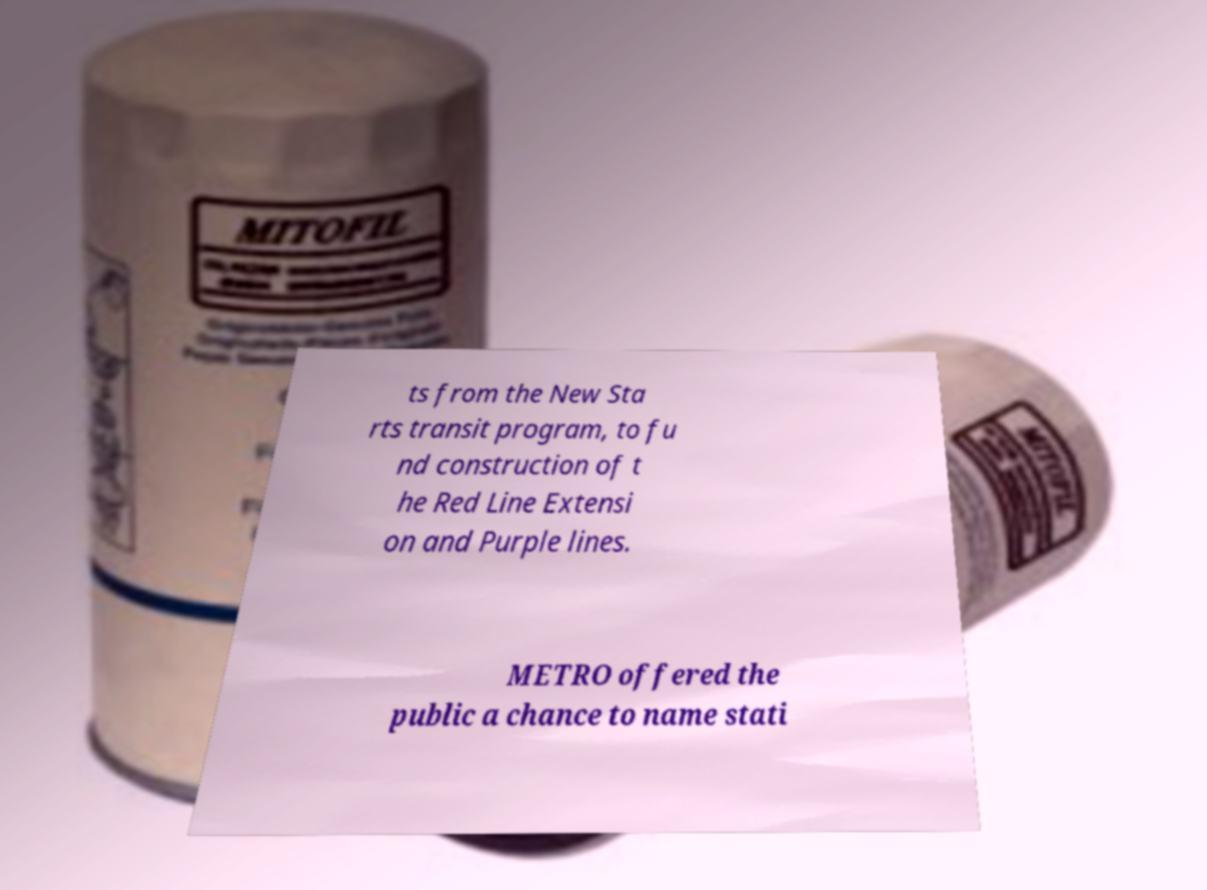Could you extract and type out the text from this image? ts from the New Sta rts transit program, to fu nd construction of t he Red Line Extensi on and Purple lines. METRO offered the public a chance to name stati 